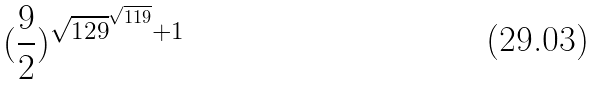Convert formula to latex. <formula><loc_0><loc_0><loc_500><loc_500>( \frac { 9 } { 2 } ) ^ { \sqrt { 1 2 9 } ^ { \sqrt { 1 1 9 } } + 1 }</formula> 